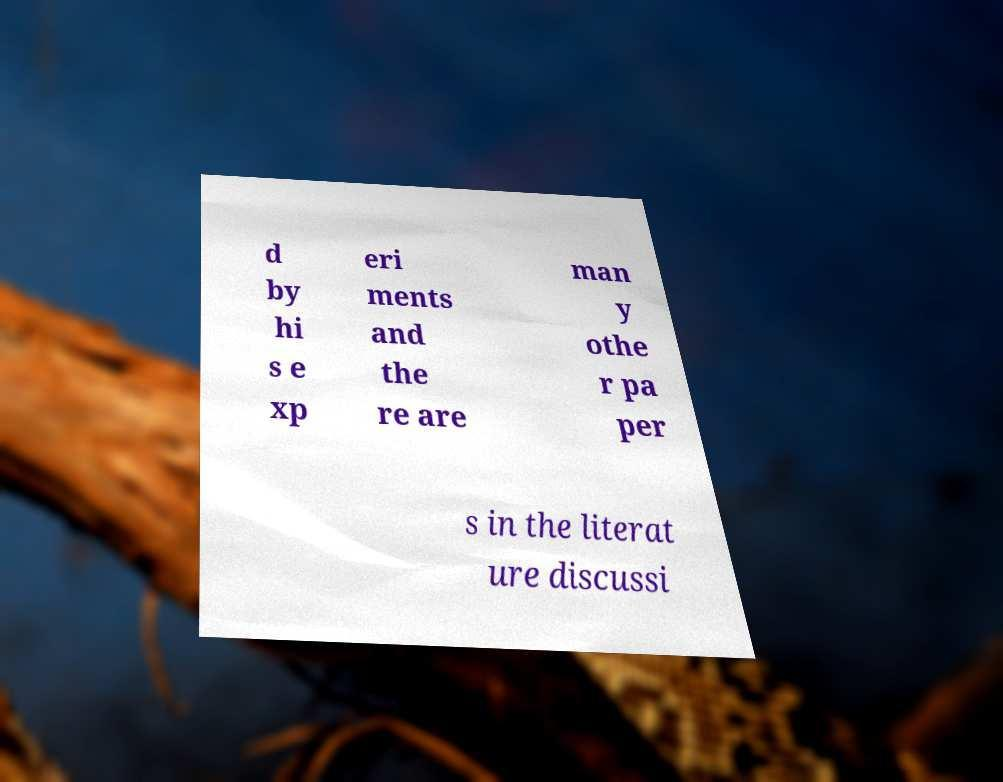Can you read and provide the text displayed in the image?This photo seems to have some interesting text. Can you extract and type it out for me? d by hi s e xp eri ments and the re are man y othe r pa per s in the literat ure discussi 